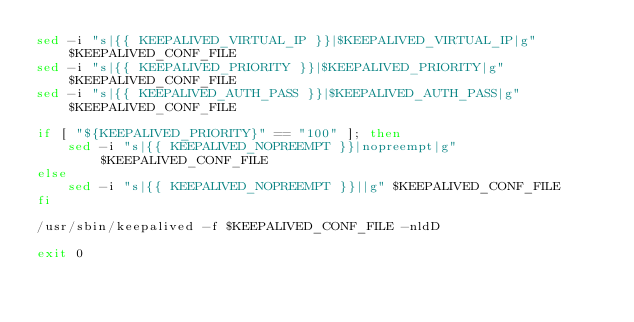Convert code to text. <code><loc_0><loc_0><loc_500><loc_500><_Bash_>sed -i "s|{{ KEEPALIVED_VIRTUAL_IP }}|$KEEPALIVED_VIRTUAL_IP|g" $KEEPALIVED_CONF_FILE
sed -i "s|{{ KEEPALIVED_PRIORITY }}|$KEEPALIVED_PRIORITY|g" $KEEPALIVED_CONF_FILE
sed -i "s|{{ KEEPALIVED_AUTH_PASS }}|$KEEPALIVED_AUTH_PASS|g" $KEEPALIVED_CONF_FILE

if [ "${KEEPALIVED_PRIORITY}" == "100" ]; then
    sed -i "s|{{ KEEPALIVED_NOPREEMPT }}|nopreempt|g" $KEEPALIVED_CONF_FILE
else
    sed -i "s|{{ KEEPALIVED_NOPREEMPT }}||g" $KEEPALIVED_CONF_FILE
fi

/usr/sbin/keepalived -f $KEEPALIVED_CONF_FILE -nldD

exit 0
</code> 